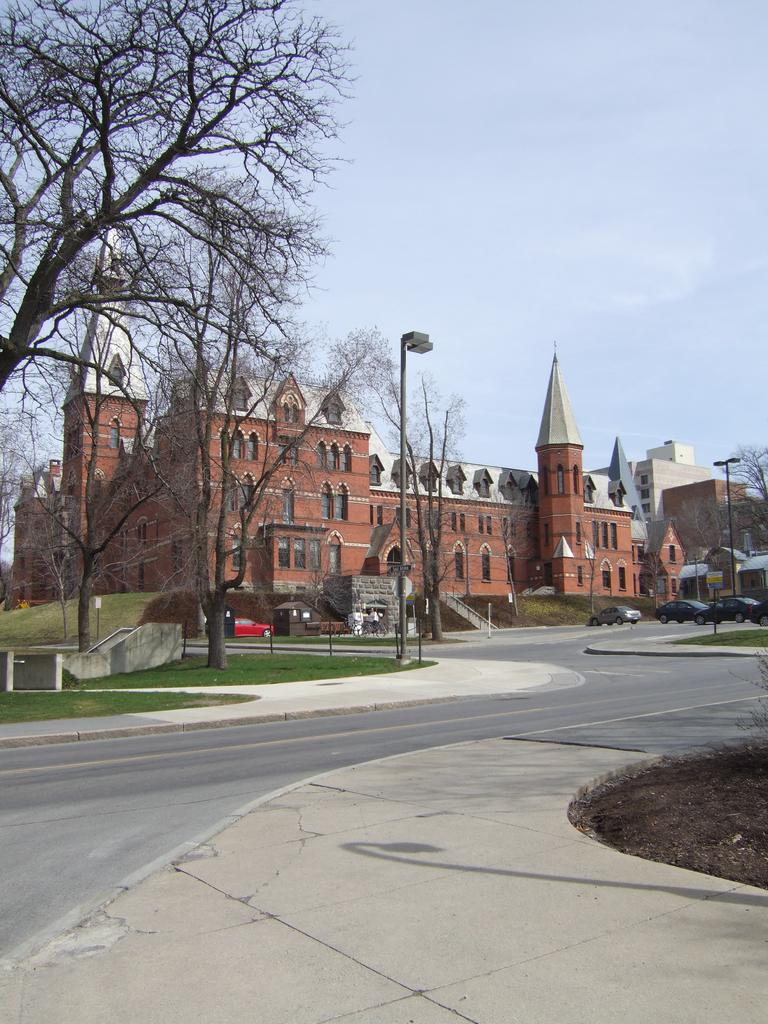What is located in the foreground of the image? There is a road in the foreground of the image. What can be seen in the background of the image? There are buildings, trees, poles, and the sky visible in the background of the image. Can you see the doll being kicked by someone in the image? There is no doll or person kicking a doll present in the image. 